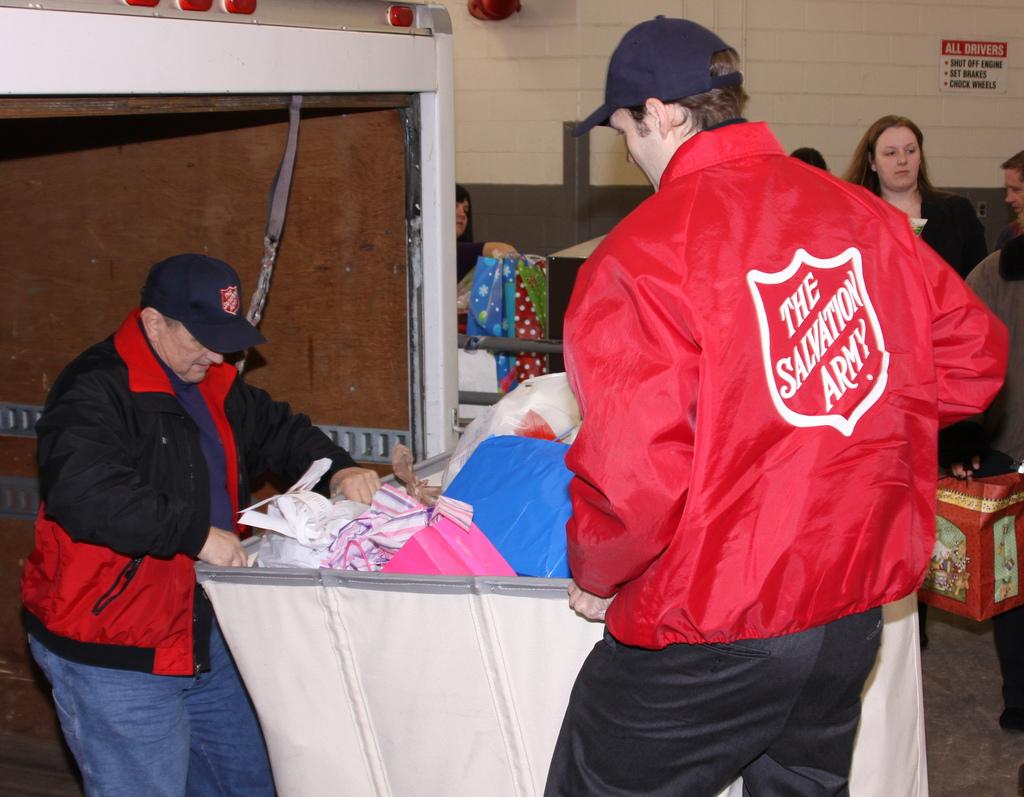What organization are these people working for?
Make the answer very short. The salvation army. Basket ball player?
Offer a terse response. No. 